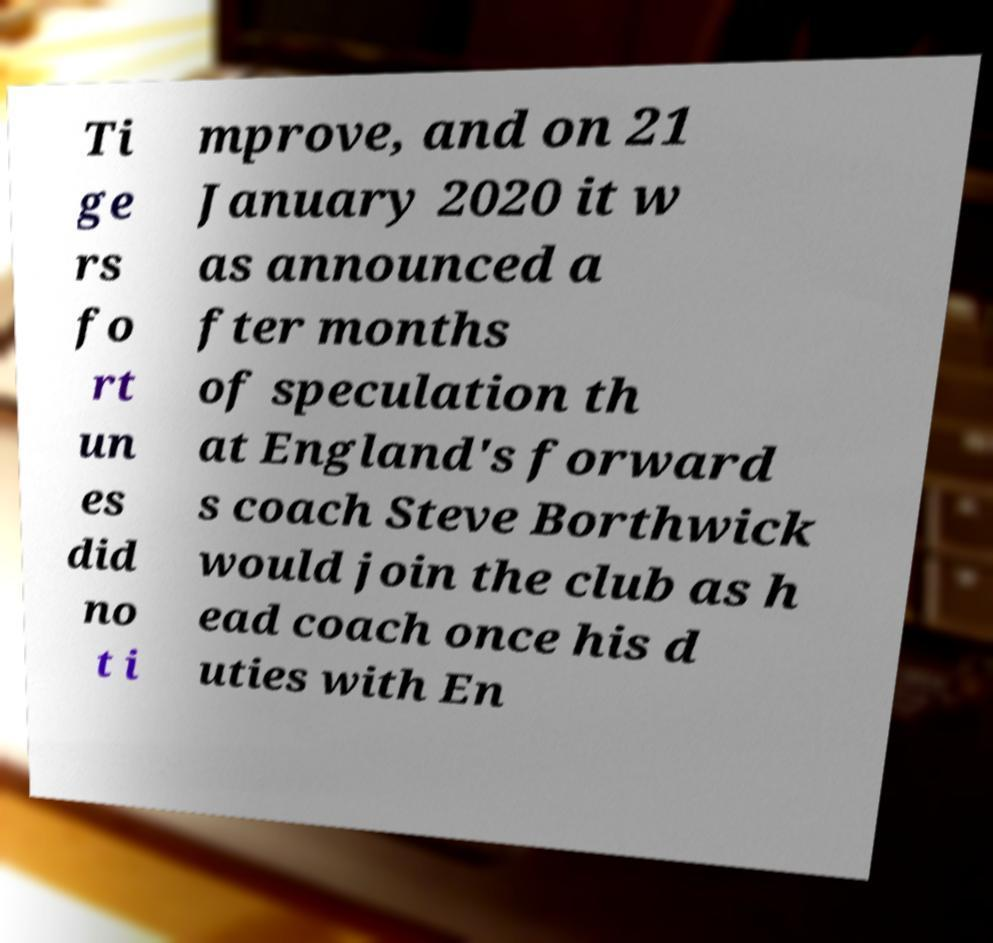Can you accurately transcribe the text from the provided image for me? Ti ge rs fo rt un es did no t i mprove, and on 21 January 2020 it w as announced a fter months of speculation th at England's forward s coach Steve Borthwick would join the club as h ead coach once his d uties with En 